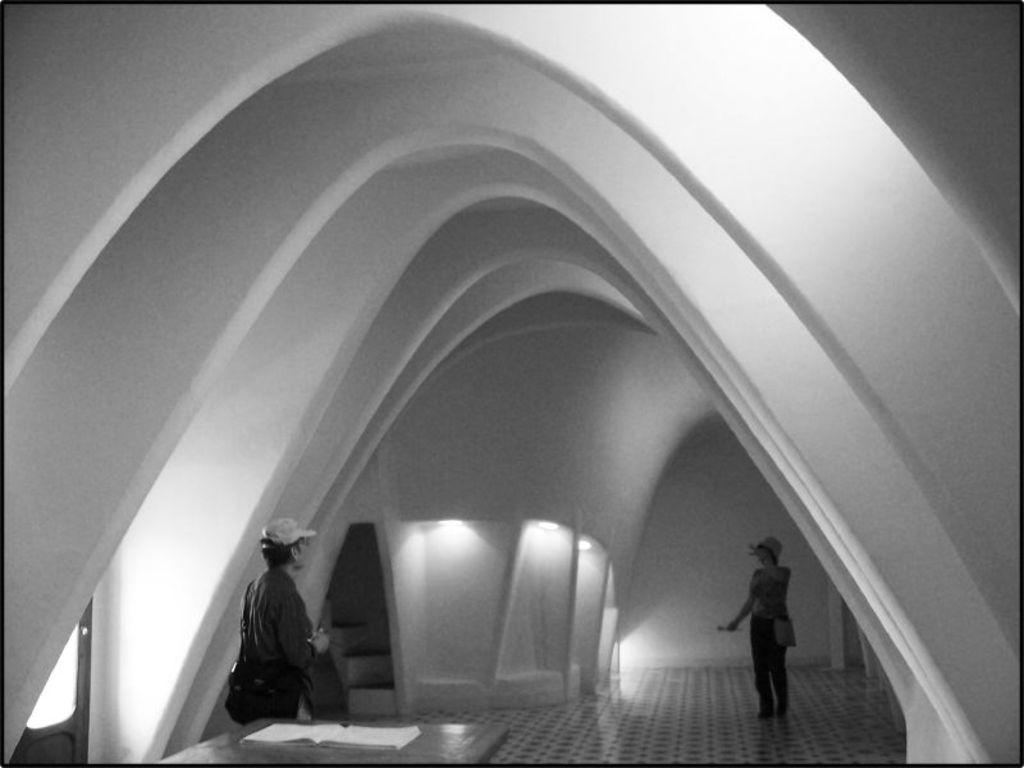What type of structure is present in the image? There is a building in the image. What architectural features can be seen in the image? There are walls and stairs visible in the image. What piece of furniture is present in the image? There is a table in the image. What object related to reading is present in the image? There is a book in the image. What part of the building is visible in the image? The floor is visible in the image. Are there any people present in the image? Yes, there are persons standing in the image. What type of star can be seen in the image? There is no star present in the image. What is the consistency of the wax in the image? There is no wax present in the image. 